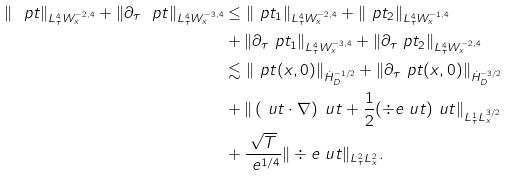Convert formula to latex. <formula><loc_0><loc_0><loc_500><loc_500>\| \ p t \| _ { L ^ { 4 } _ { \tau } W ^ { - 2 , 4 } _ { x } } + \| \partial _ { \tau } \ p t \| _ { L ^ { 4 } _ { \tau } W ^ { - 3 , 4 } _ { x } } & \leq \| \ p t _ { 1 } \| _ { L ^ { 4 } _ { \tau } W ^ { - 2 , 4 } _ { x } } + \| \ p t _ { 2 } \| _ { L ^ { 4 } _ { \tau } W ^ { - 1 , 4 } _ { x } } \\ & + \| \partial _ { \tau } \ p t _ { 1 } \| _ { L ^ { 4 } _ { \tau } W ^ { - 3 , 4 } _ { x } } + \| \partial _ { \tau } \ p t _ { 2 } \| _ { L ^ { 4 } _ { \tau } W ^ { - 2 , 4 } _ { x } } \\ & \lesssim \| \ p t ( x , 0 ) \| _ { \dot { H } ^ { - 1 / 2 } _ { D } } + \| \partial _ { \tau } \ p t ( x , 0 ) \| _ { \dot { H } ^ { - 3 / 2 } _ { D } } \\ & + \| \left ( \ u t \cdot \nabla \right ) \ u t + \frac { 1 } { 2 } ( \div e \ u t ) \ u t \| _ { L ^ { 1 } _ { \tau } L ^ { 3 / 2 } _ { x } } \\ & + \frac { \sqrt { T } } { \ e ^ { 1 / 4 } } \| \div e \ u t \| _ { L ^ { 2 } _ { \tau } L ^ { 2 } _ { x } } .</formula> 